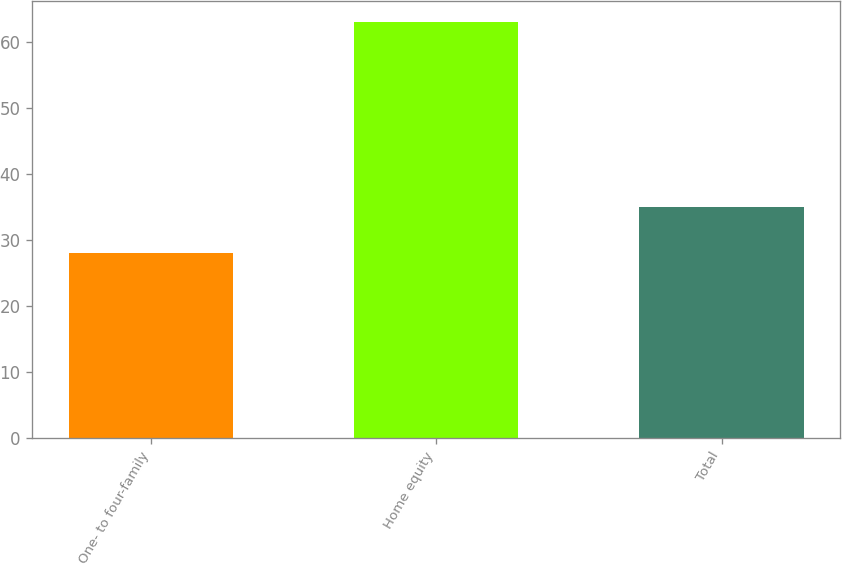Convert chart to OTSL. <chart><loc_0><loc_0><loc_500><loc_500><bar_chart><fcel>One- to four-family<fcel>Home equity<fcel>Total<nl><fcel>28<fcel>63<fcel>35<nl></chart> 